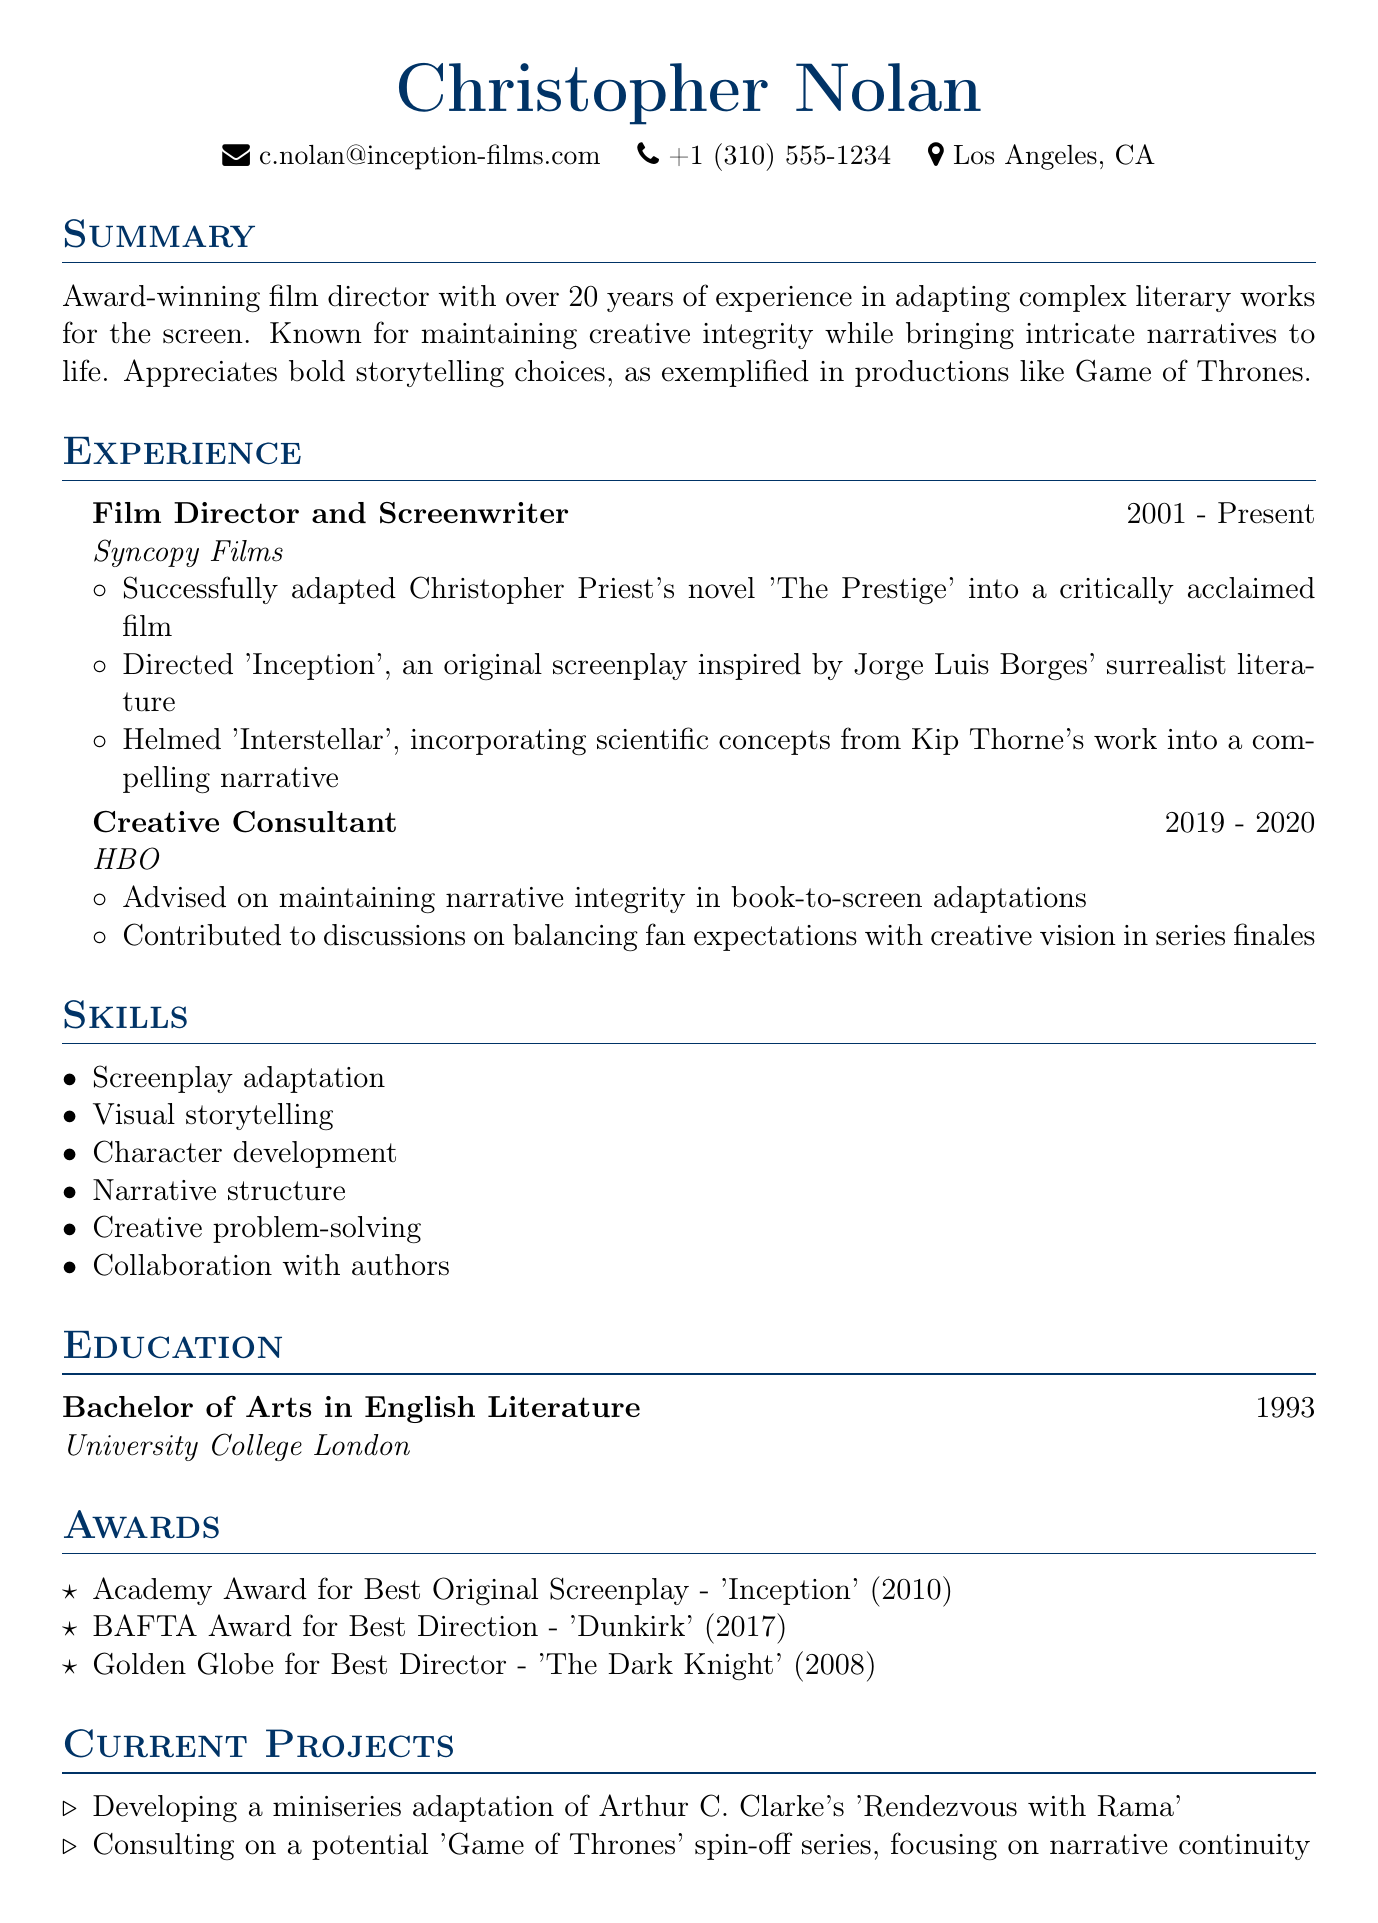What is the name of the film director? The name listed in the document is the individual’s full name situated at the top of the CV.
Answer: Christopher Nolan What is the email address provided? The email is typically found in the personal information section of the CV.
Answer: c.nolan@inception-films.com What company is associated with the majority of the director's work? The director's long-term association is documented in the experience section, identifying the company he has been with since 2001.
Answer: Syncopy Films What degree did he earn? The education section specifies the highest degree obtained, along with the field of study and the institution.
Answer: Bachelor of Arts in English Literature In which year did he graduate? The graduation year is found in the education section and represents when the degree was completed.
Answer: 1993 What is one notable award he has received? Awards received by the individual are listed in the corresponding section showcasing his achievements.
Answer: Academy Award for Best Original Screenplay - 'Inception' Which literary work is he currently adapting into a miniseries? This information is found in the projects section detailing current engagements and adaptations.
Answer: Arthur C. Clarke's 'Rendezvous with Rama' What is the focus of the potential 'Game of Thrones' spin-off he is consulting on? The project description in the current projects section indicates the specific narrative aspect he is addressing.
Answer: Narrative continuity How many years of experience does he have adapting literary works? The summary indicates the total experience mentioned in years.
Answer: Over 20 years What type of storytelling does he appreciate, as exemplified in the document? Insights into his preferences are shared in the summary, reflecting his appreciation for particular styles.
Answer: Bold storytelling choices 